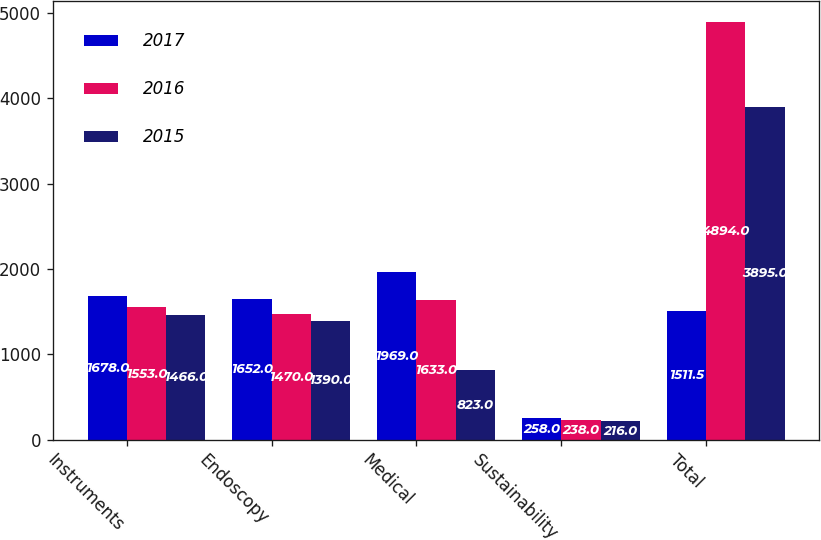<chart> <loc_0><loc_0><loc_500><loc_500><stacked_bar_chart><ecel><fcel>Instruments<fcel>Endoscopy<fcel>Medical<fcel>Sustainability<fcel>Total<nl><fcel>2017<fcel>1678<fcel>1652<fcel>1969<fcel>258<fcel>1511.5<nl><fcel>2016<fcel>1553<fcel>1470<fcel>1633<fcel>238<fcel>4894<nl><fcel>2015<fcel>1466<fcel>1390<fcel>823<fcel>216<fcel>3895<nl></chart> 